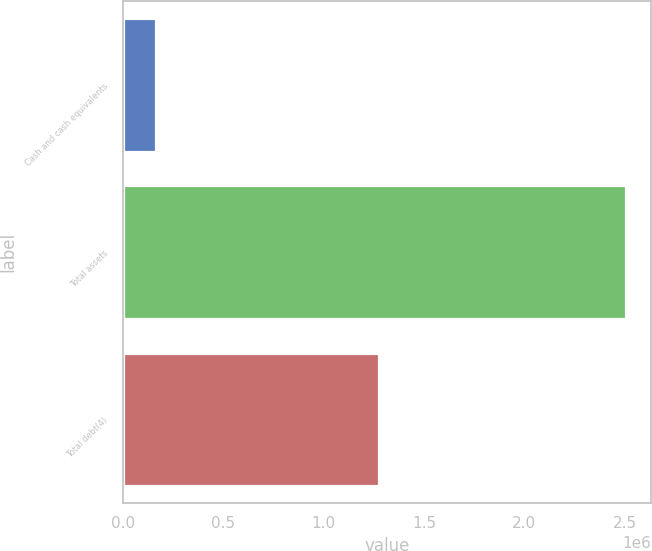Convert chart to OTSL. <chart><loc_0><loc_0><loc_500><loc_500><bar_chart><fcel>Cash and cash equivalents<fcel>Total assets<fcel>Total debt(4)<nl><fcel>165801<fcel>2.50445e+06<fcel>1.27589e+06<nl></chart> 